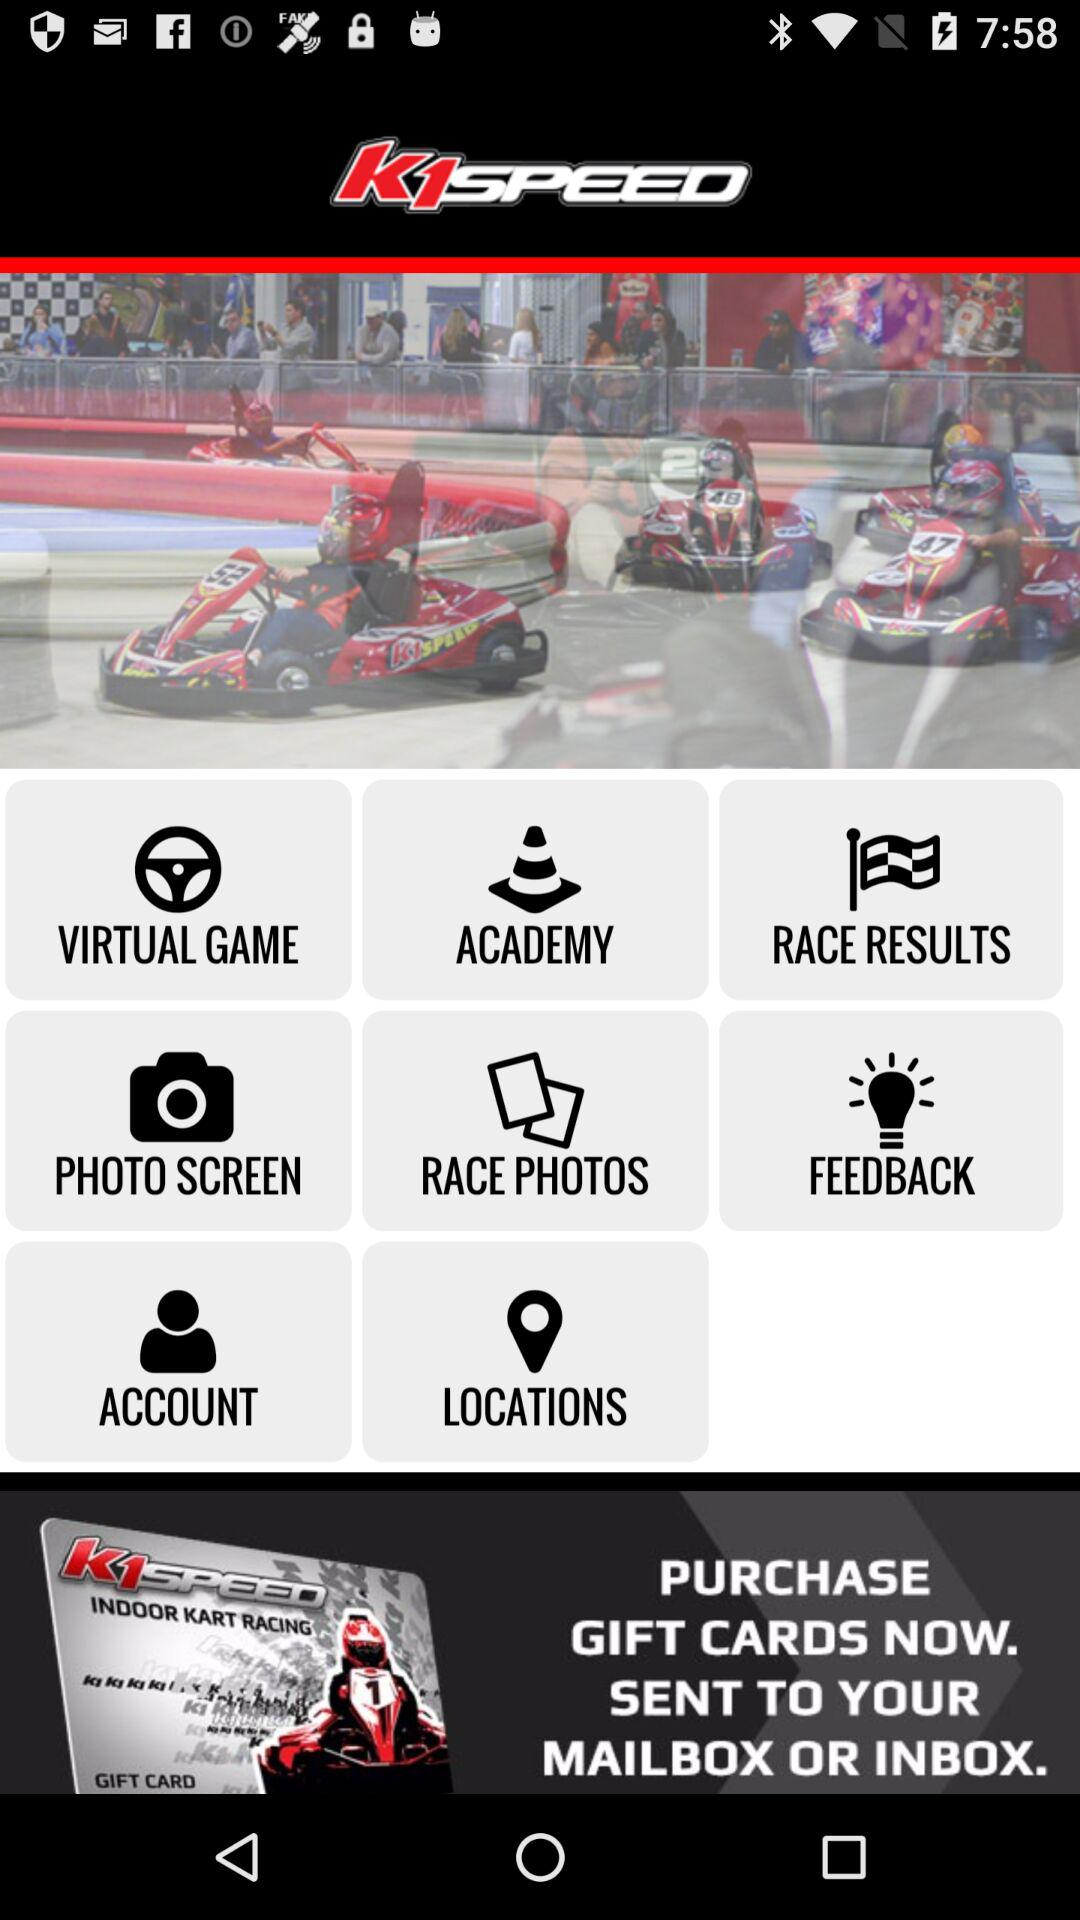What is the name of the application? The name of the application is "k1SPEED". 